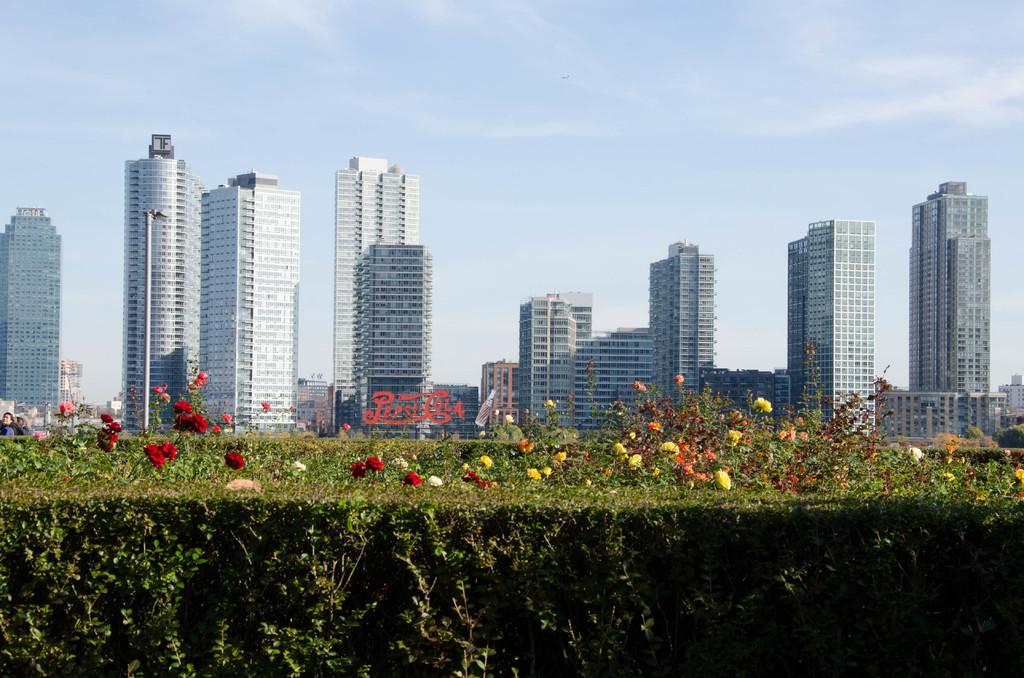What celestial bodies are depicted in the image? There are planets in the image. What type of flora is present in the image? There are colorful flowers in the image. What type of structures can be seen in the background of the image? There are buildings in the background of the image. What is the condition of the sky in the image? The sky is clear in the image. What type of cake is being served in the image? There is no cake present in the image; it features planets, flowers, buildings, and a clear sky. Can you tell me which book is being read by the person in the image? There is no person or book present in the image. 